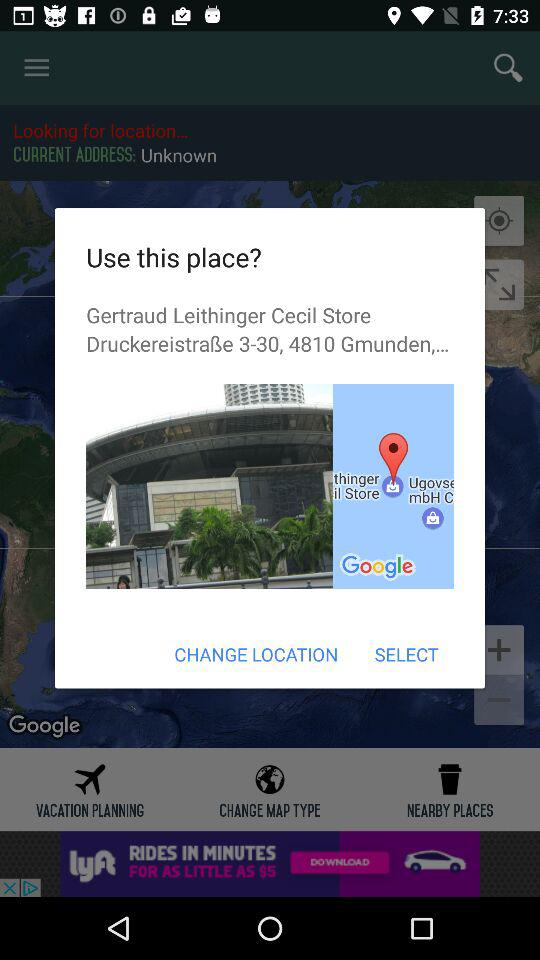What is the given location? The given location is "Druckereistraße 3-30, 4810 Gmunden,...". 